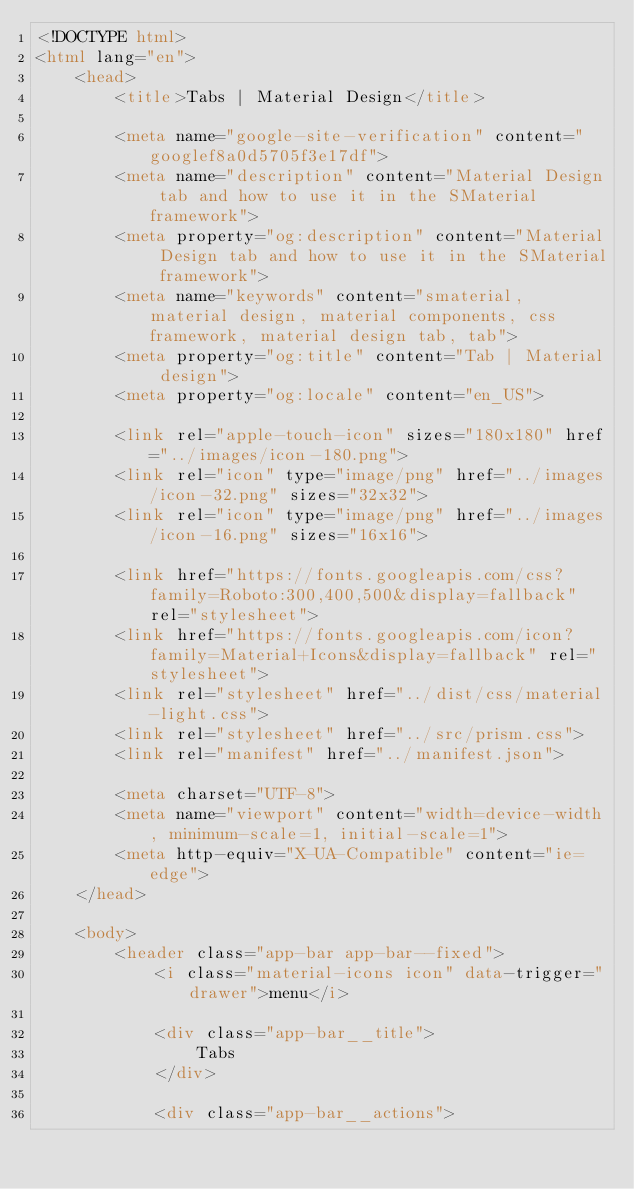<code> <loc_0><loc_0><loc_500><loc_500><_HTML_><!DOCTYPE html>
<html lang="en">
    <head>
        <title>Tabs | Material Design</title>

        <meta name="google-site-verification" content="googlef8a0d5705f3e17df">
        <meta name="description" content="Material Design tab and how to use it in the SMaterial framework">
        <meta property="og:description" content="Material Design tab and how to use it in the SMaterial framework">
        <meta name="keywords" content="smaterial, material design, material components, css framework, material design tab, tab">
        <meta property="og:title" content="Tab | Material design">
        <meta property="og:locale" content="en_US">

        <link rel="apple-touch-icon" sizes="180x180" href="../images/icon-180.png">
        <link rel="icon" type="image/png" href="../images/icon-32.png" sizes="32x32">
        <link rel="icon" type="image/png" href="../images/icon-16.png" sizes="16x16">

        <link href="https://fonts.googleapis.com/css?family=Roboto:300,400,500&display=fallback" rel="stylesheet">
        <link href="https://fonts.googleapis.com/icon?family=Material+Icons&display=fallback" rel="stylesheet">
        <link rel="stylesheet" href="../dist/css/material-light.css">
        <link rel="stylesheet" href="../src/prism.css">
        <link rel="manifest" href="../manifest.json">

        <meta charset="UTF-8">
        <meta name="viewport" content="width=device-width, minimum-scale=1, initial-scale=1">
        <meta http-equiv="X-UA-Compatible" content="ie=edge">
    </head>

    <body>
        <header class="app-bar app-bar--fixed">
            <i class="material-icons icon" data-trigger="drawer">menu</i>

            <div class="app-bar__title">
                Tabs
            </div>

            <div class="app-bar__actions"></code> 